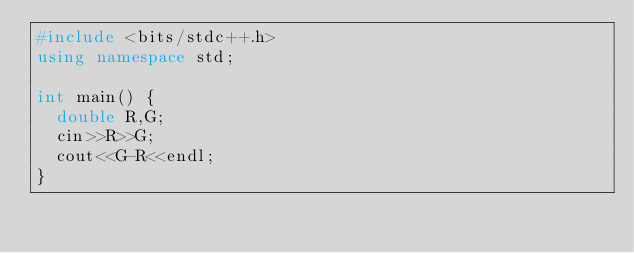<code> <loc_0><loc_0><loc_500><loc_500><_C++_>#include <bits/stdc++.h>
using namespace std;

int main() {
  double R,G;
  cin>>R>>G;
  cout<<G-R<<endl;
}</code> 